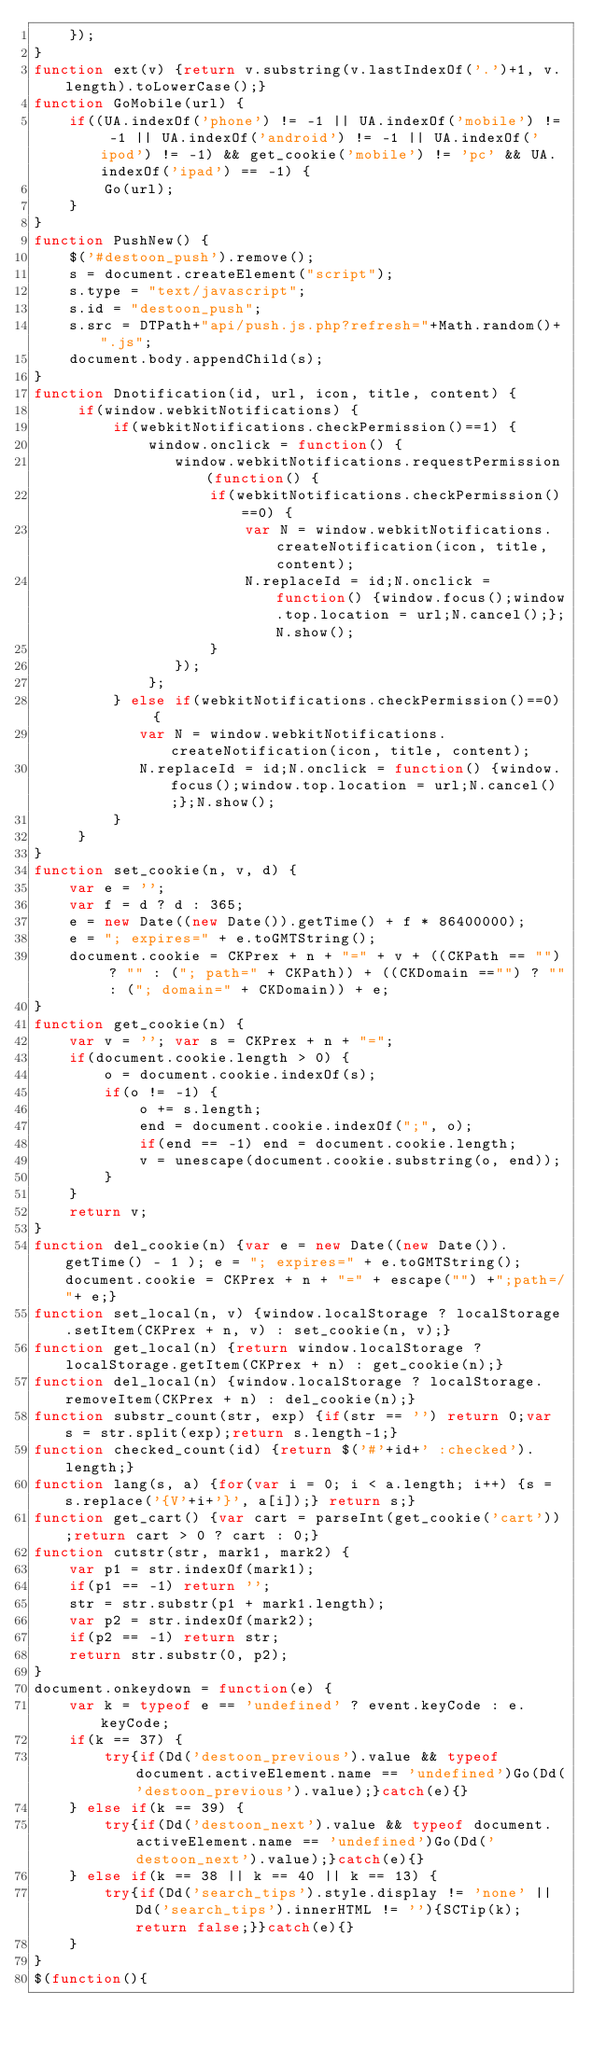Convert code to text. <code><loc_0><loc_0><loc_500><loc_500><_JavaScript_>	});
}
function ext(v) {return v.substring(v.lastIndexOf('.')+1, v.length).toLowerCase();}
function GoMobile(url) {
	if((UA.indexOf('phone') != -1 || UA.indexOf('mobile') != -1 || UA.indexOf('android') != -1 || UA.indexOf('ipod') != -1) && get_cookie('mobile') != 'pc' && UA.indexOf('ipad') == -1) {
		Go(url);
	}
}
function PushNew() {
	$('#destoon_push').remove();
	s = document.createElement("script");
	s.type = "text/javascript";
	s.id = "destoon_push";
	s.src = DTPath+"api/push.js.php?refresh="+Math.random()+".js";
	document.body.appendChild(s);
}
function Dnotification(id, url, icon, title, content) {
	 if(window.webkitNotifications) {
		 if(webkitNotifications.checkPermission()==1) {
			 window.onclick = function() {
				window.webkitNotifications.requestPermission(function() {
					if(webkitNotifications.checkPermission()==0) {						
						var N = window.webkitNotifications.createNotification(icon, title, content);
						N.replaceId = id;N.onclick = function() {window.focus();window.top.location = url;N.cancel();};N.show();
					}
				});
			 };
		 } else if(webkitNotifications.checkPermission()==0) {	
			var N = window.webkitNotifications.createNotification(icon, title, content);
			N.replaceId = id;N.onclick = function() {window.focus();window.top.location = url;N.cancel();};N.show();
		 }
	 }
}
function set_cookie(n, v, d) {
	var e = ''; 
	var f = d ? d : 365;
	e = new Date((new Date()).getTime() + f * 86400000);
	e = "; expires=" + e.toGMTString();
	document.cookie = CKPrex + n + "=" + v + ((CKPath == "") ? "" : ("; path=" + CKPath)) + ((CKDomain =="") ? "" : ("; domain=" + CKDomain)) + e; 
}
function get_cookie(n) {
	var v = ''; var s = CKPrex + n + "=";
	if(document.cookie.length > 0) {
		o = document.cookie.indexOf(s);
		if(o != -1) {	
			o += s.length;
			end = document.cookie.indexOf(";", o);
			if(end == -1) end = document.cookie.length;
			v = unescape(document.cookie.substring(o, end));
		}
	}
	return v;
}
function del_cookie(n) {var e = new Date((new Date()).getTime() - 1 ); e = "; expires=" + e.toGMTString(); document.cookie = CKPrex + n + "=" + escape("") +";path=/"+ e;}
function set_local(n, v) {window.localStorage ? localStorage.setItem(CKPrex + n, v) : set_cookie(n, v);}
function get_local(n) {return window.localStorage ? localStorage.getItem(CKPrex + n) : get_cookie(n);}
function del_local(n) {window.localStorage ? localStorage.removeItem(CKPrex + n) : del_cookie(n);}
function substr_count(str, exp) {if(str == '') return 0;var s = str.split(exp);return s.length-1;}
function checked_count(id) {return $('#'+id+' :checked').length;}
function lang(s, a) {for(var i = 0; i < a.length; i++) {s = s.replace('{V'+i+'}', a[i]);} return s;}
function get_cart() {var cart = parseInt(get_cookie('cart'));return cart > 0 ? cart : 0;}
function cutstr(str, mark1, mark2) {
	var p1 = str.indexOf(mark1);
	if(p1 == -1) return '';
	str = str.substr(p1 + mark1.length);
	var p2 = str.indexOf(mark2);
	if(p2 == -1) return str;
	return str.substr(0, p2);
}
document.onkeydown = function(e) {
	var k = typeof e == 'undefined' ? event.keyCode : e.keyCode;
	if(k == 37) {
		try{if(Dd('destoon_previous').value && typeof document.activeElement.name == 'undefined')Go(Dd('destoon_previous').value);}catch(e){}
	} else if(k == 39) {
		try{if(Dd('destoon_next').value && typeof document.activeElement.name == 'undefined')Go(Dd('destoon_next').value);}catch(e){}
	} else if(k == 38 || k == 40 || k == 13) {
		try{if(Dd('search_tips').style.display != 'none' || Dd('search_tips').innerHTML != ''){SCTip(k);return false;}}catch(e){}
	}
}
$(function(){</code> 